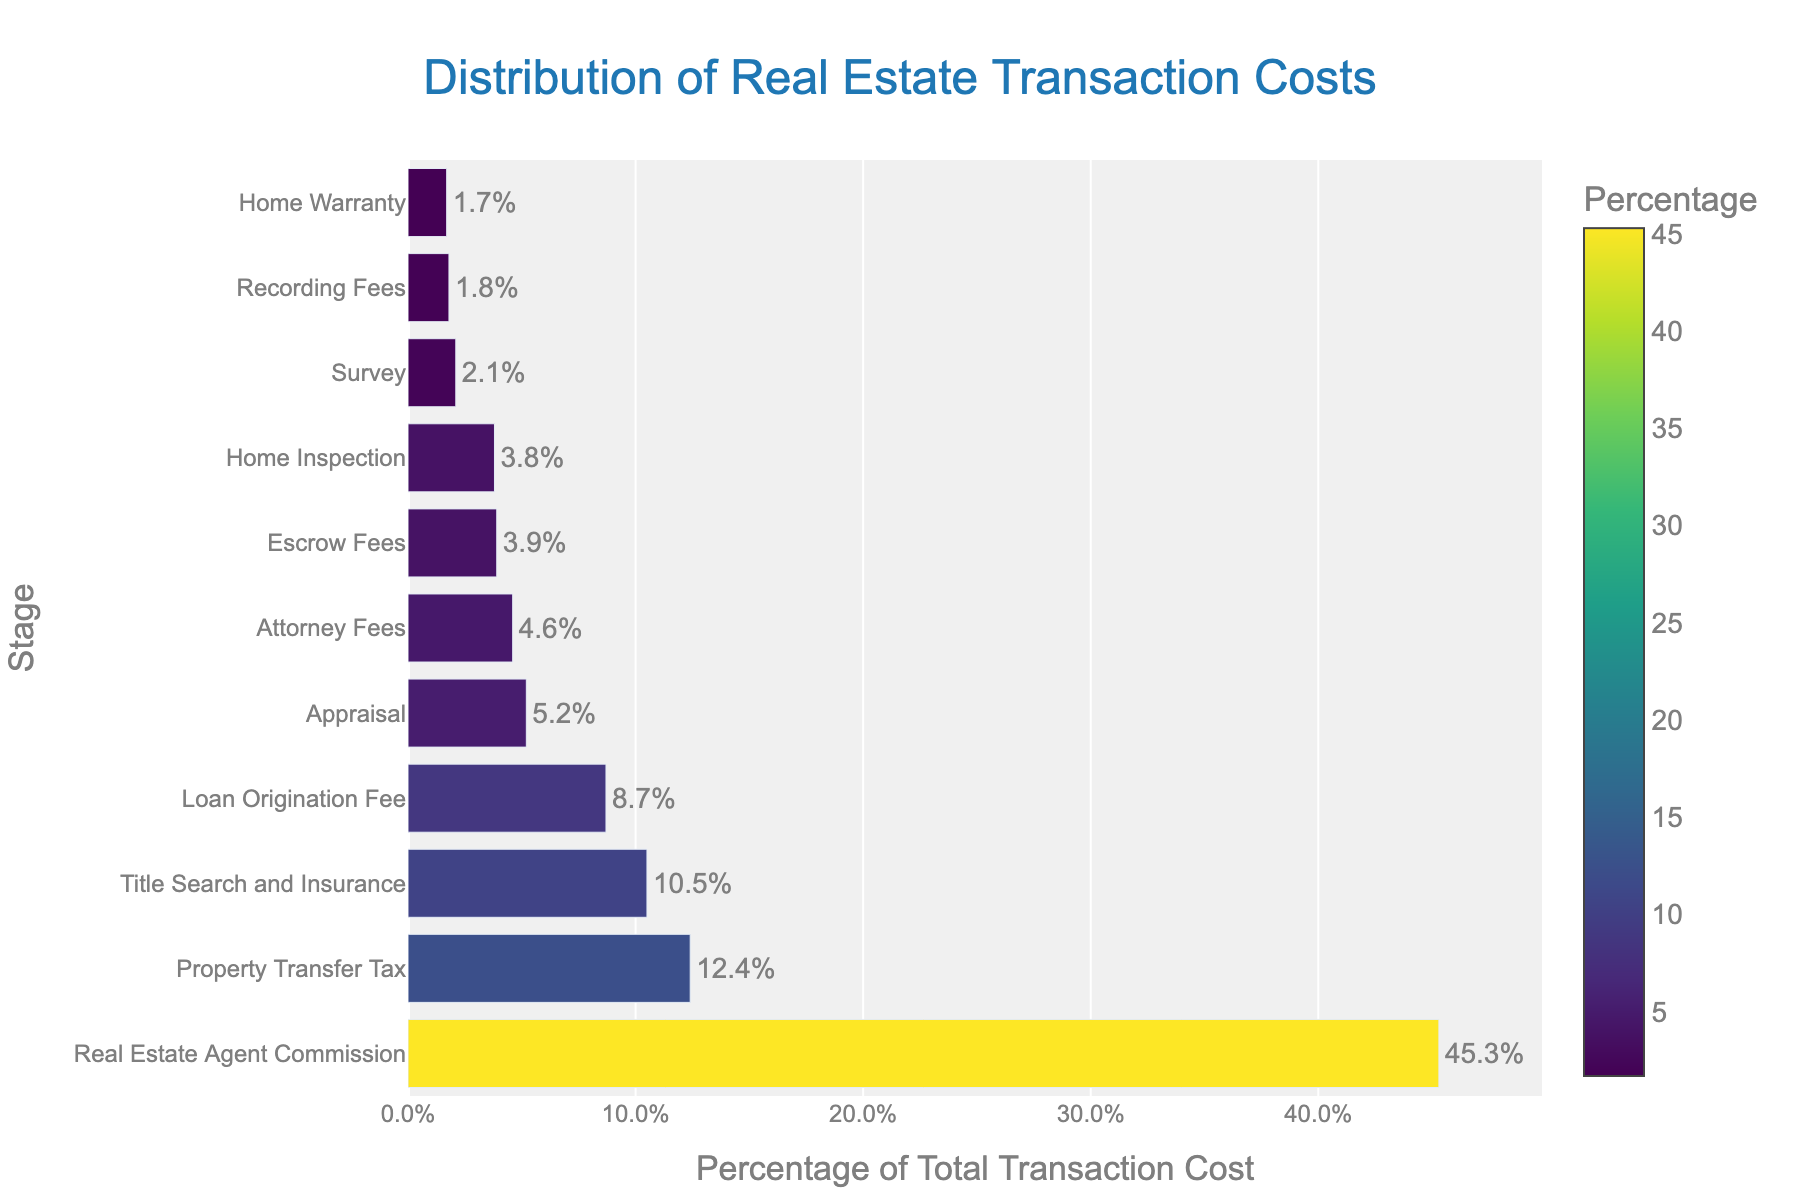What is the most significant cost stage in the real estate transaction? The bar representing the real estate agent commission is the longest, and the percentage label on the bar shows 45.3%, which is the highest value in the chart.
Answer: Real estate agent commission Which stage has the lowest percentage of the total transaction cost? The bar representing the home warranty is the shortest, and the percentage label on the bar shows 1.7%, which is the smallest value in the chart.
Answer: Home warranty How much more does the real estate agent commission cost compared to the loan origination fee? The percentage for real estate agent commission is 45.3%, and for loan origination fee, it is 8.7%. The difference is calculated as 45.3% - 8.7%.
Answer: 36.6% Which stages together account for more than 50% of the total transaction cost? Adding the percentages for the stages, starting with the highest: Real estate agent commission (45.3%) + Property transfer tax (12.4%) = 57.7%. Since 57.7% exceeds 50%, only these two stages are needed.
Answer: Real estate agent commission and property transfer tax What is the combined percentage for appraisal, home inspection, and attorney fees? Sum the percentages of these stages: Appraisal (5.2%) + Home inspection (3.8%) + Attorney fees (4.6%).
Answer: 13.6% Which stage incurs approximately half of the cost of the real estate agent commission? Half of the real estate agent commission (45.3%) is 22.65%. By comparing this with other stages, property transfer tax with 12.4% is closest to half of the agent commission among the listed stages.
Answer: Property transfer tax What is the difference in percentages between title search and insurance and appraisal? Title search and insurance cost is 10.5%, and appraisal cost is 5.2%. The difference is calculated as 10.5% - 5.2%.
Answer: 5.3% Which stages have costs represented by blue to green color bars? The Viridis colorscale used ranges from blue to green. The stages with lower percentages like recording fees (1.8%), home warranty (1.7%), and survey (2.1%) fall into this colorspace.
Answer: Recording fees, home warranty, survey What percentage of the total transaction cost do all inspection-related stages account for? Inspection-related stages include home inspection (3.8%) and survey (2.1%). The combined percentage is 3.8% + 2.1%.
Answer: 5.9% Which two stages have the closest percentage values of the total transaction cost, and what are these values? Home inspection (3.8%) and escrow fees (3.9%) are closest, differing by only 0.1%.
Answer: Home inspection (3.8%) and escrow fees (3.9%) 